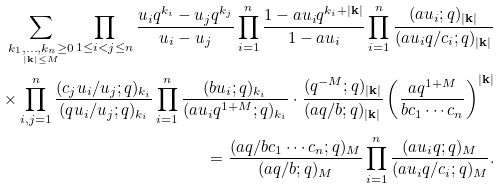<formula> <loc_0><loc_0><loc_500><loc_500>\sum _ { \underset { | { \mathbf k } | \leq M } { k _ { 1 } , \dots , k _ { n } \geq 0 } } \prod _ { 1 \leq i < j \leq n } \frac { u _ { i } q ^ { k _ { i } } - u _ { j } q ^ { k _ { j } } } { u _ { i } - u _ { j } } \prod _ { i = 1 } ^ { n } \frac { 1 - a u _ { i } q ^ { k _ { i } + | { \mathbf k } | } } { 1 - a u _ { i } } \prod _ { i = 1 } ^ { n } \frac { ( a u _ { i } ; q ) _ { | { \mathbf k } | } } { ( a u _ { i } q / c _ { i } ; q ) _ { | { \mathbf k } | } } \\ \times \prod _ { i , j = 1 } ^ { n } \frac { ( c _ { j } u _ { i } / u _ { j } ; q ) _ { k _ { i } } } { ( q u _ { i } / u _ { j } ; q ) _ { k _ { i } } } \prod _ { i = 1 } ^ { n } \frac { ( b u _ { i } ; q ) _ { k _ { i } } } { ( a u _ { i } q ^ { 1 + M } ; q ) _ { k _ { i } } } \cdot \frac { ( q ^ { - M } ; q ) _ { | { \mathbf k } | } } { ( a q / b ; q ) _ { | { \mathbf k } | } } \left ( \frac { a q ^ { 1 + M } } { b c _ { 1 } \cdots c _ { n } } \right ) ^ { | { \mathbf k } | } \\ = \frac { ( a q / b c _ { 1 } \cdots c _ { n } ; q ) _ { M } } { ( a q / b ; q ) _ { M } } \prod _ { i = 1 } ^ { n } \frac { ( a u _ { i } q ; q ) _ { M } } { ( a u _ { i } q / c _ { i } ; q ) _ { M } } .</formula> 